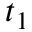<formula> <loc_0><loc_0><loc_500><loc_500>t _ { 1 }</formula> 